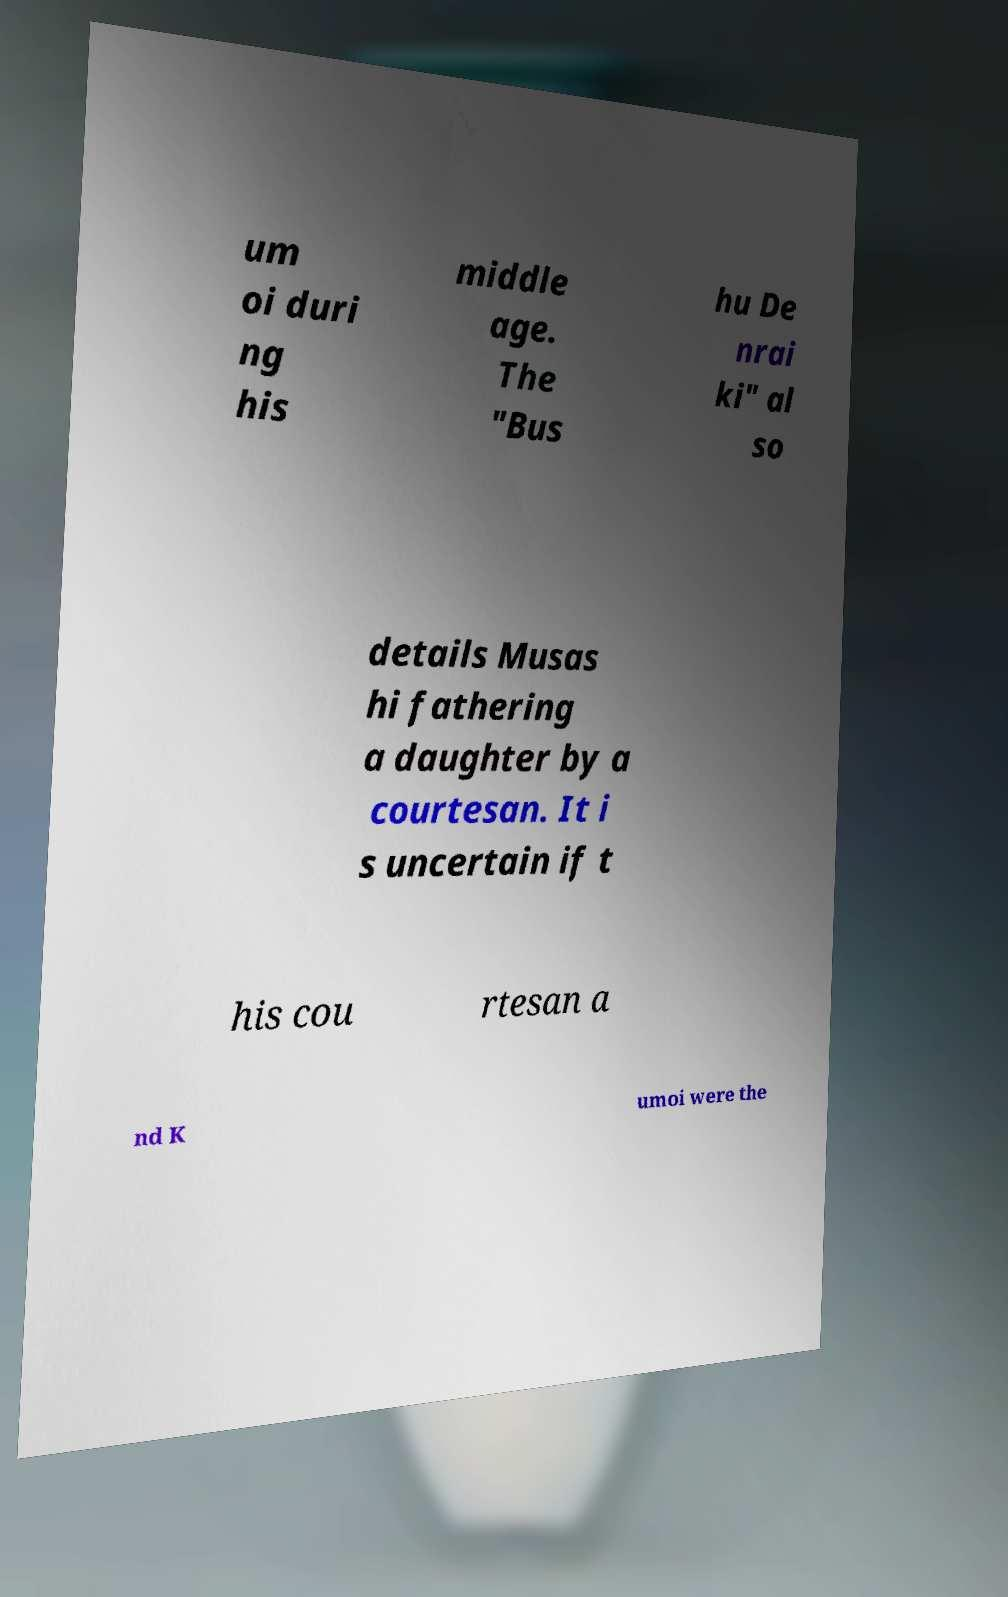What messages or text are displayed in this image? I need them in a readable, typed format. um oi duri ng his middle age. The "Bus hu De nrai ki" al so details Musas hi fathering a daughter by a courtesan. It i s uncertain if t his cou rtesan a nd K umoi were the 